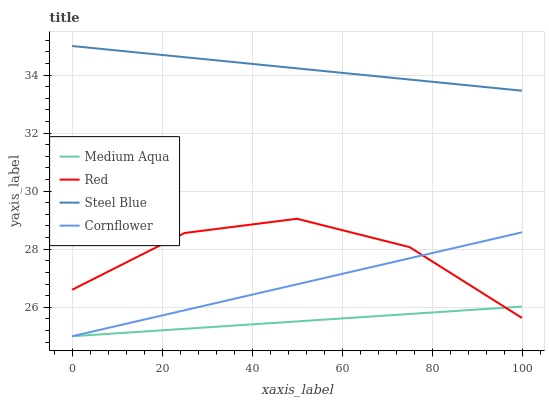Does Medium Aqua have the minimum area under the curve?
Answer yes or no. Yes. Does Steel Blue have the maximum area under the curve?
Answer yes or no. Yes. Does Steel Blue have the minimum area under the curve?
Answer yes or no. No. Does Medium Aqua have the maximum area under the curve?
Answer yes or no. No. Is Cornflower the smoothest?
Answer yes or no. Yes. Is Red the roughest?
Answer yes or no. Yes. Is Medium Aqua the smoothest?
Answer yes or no. No. Is Medium Aqua the roughest?
Answer yes or no. No. Does Cornflower have the lowest value?
Answer yes or no. Yes. Does Steel Blue have the lowest value?
Answer yes or no. No. Does Steel Blue have the highest value?
Answer yes or no. Yes. Does Medium Aqua have the highest value?
Answer yes or no. No. Is Red less than Steel Blue?
Answer yes or no. Yes. Is Steel Blue greater than Cornflower?
Answer yes or no. Yes. Does Medium Aqua intersect Red?
Answer yes or no. Yes. Is Medium Aqua less than Red?
Answer yes or no. No. Is Medium Aqua greater than Red?
Answer yes or no. No. Does Red intersect Steel Blue?
Answer yes or no. No. 